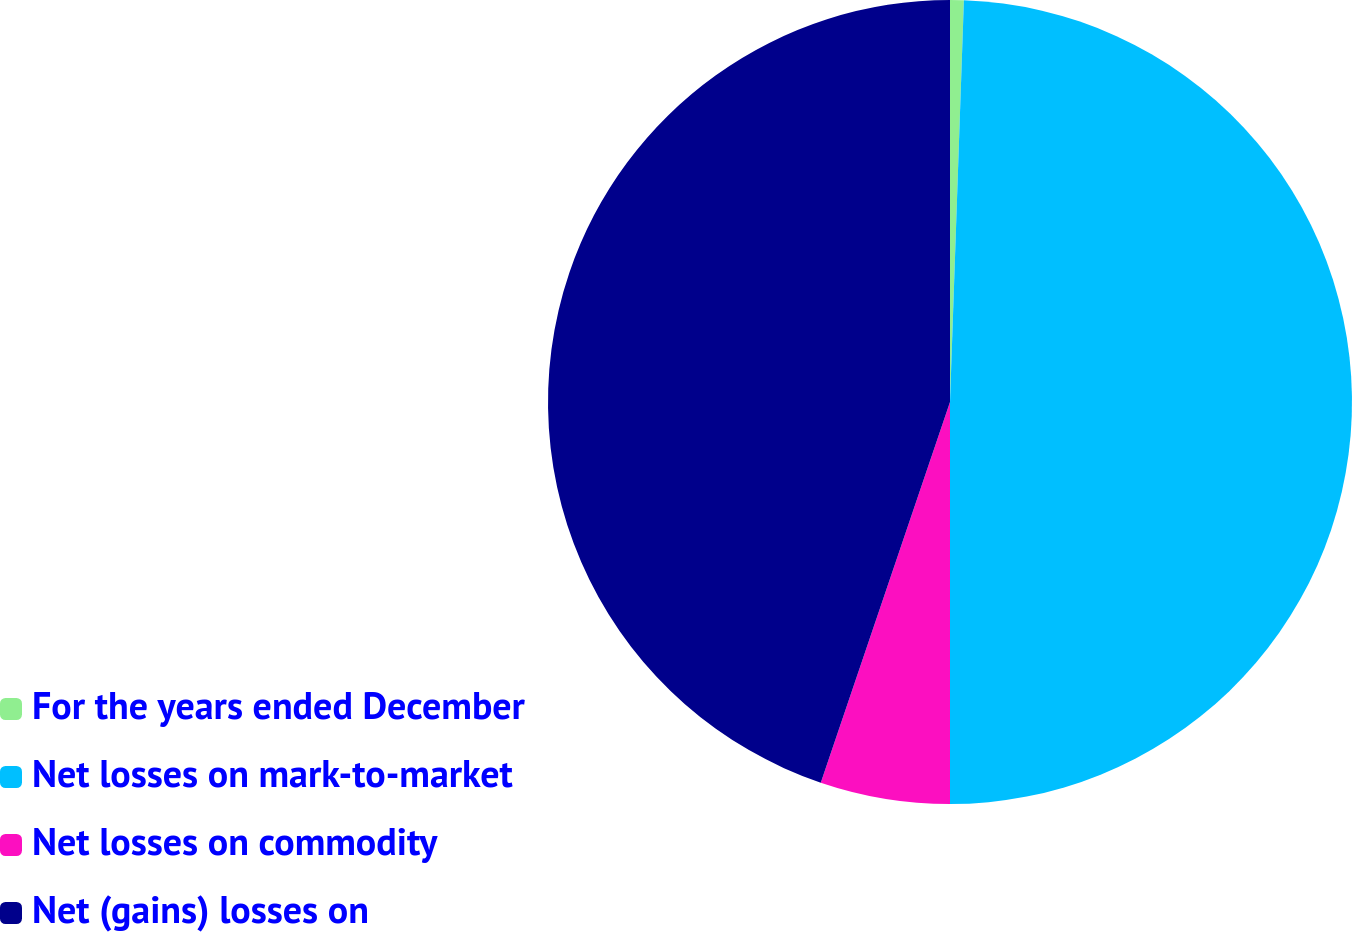Convert chart. <chart><loc_0><loc_0><loc_500><loc_500><pie_chart><fcel>For the years ended December<fcel>Net losses on mark-to-market<fcel>Net losses on commodity<fcel>Net (gains) losses on<nl><fcel>0.55%<fcel>49.45%<fcel>5.21%<fcel>44.79%<nl></chart> 